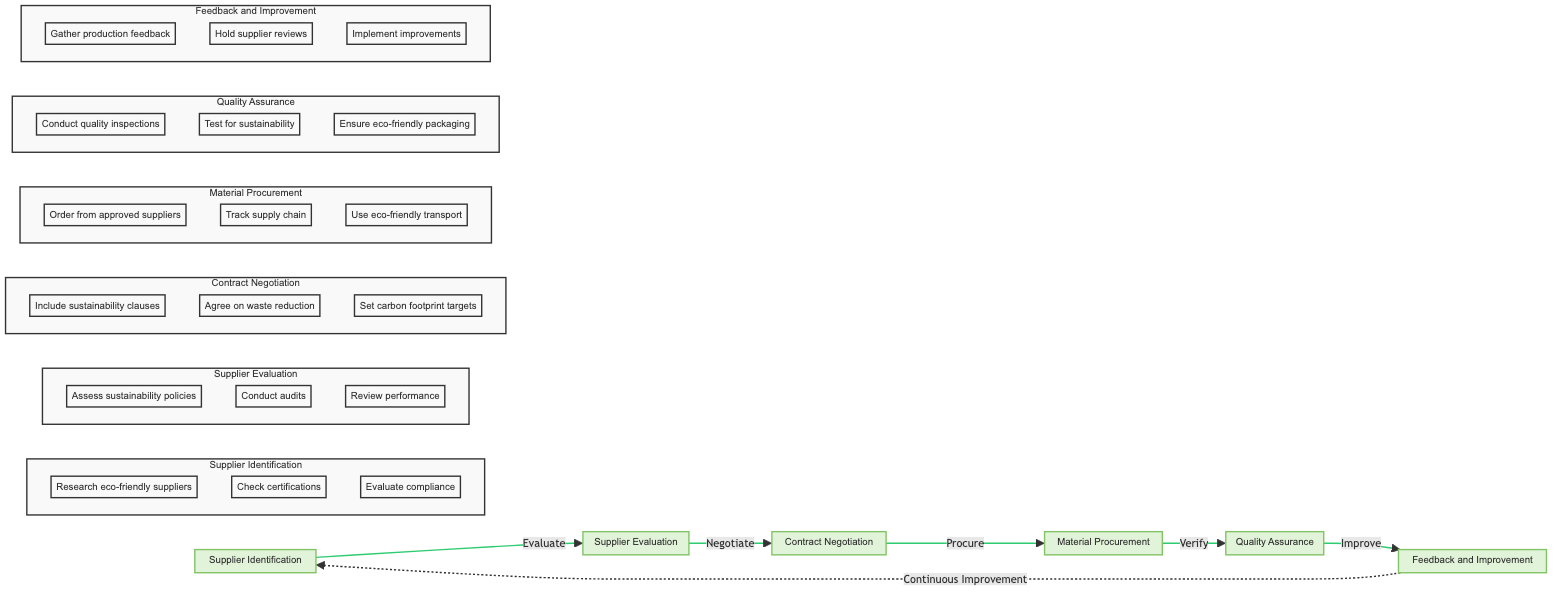What are the main steps in the sustainable material procurement process? The diagram outlines six main steps: Supplier Identification, Supplier Evaluation, Contract Negotiation, Material Procurement, Quality Assurance, and Feedback and Improvement.
Answer: Supplier Identification, Supplier Evaluation, Contract Negotiation, Material Procurement, Quality Assurance, Feedback and Improvement What is the starting point of the diagram? The horizontal flowchart begins with the Supplier Identification node, which is the first step in the sustainable material procurement process.
Answer: Supplier Identification How many nodes are in the diagram? The diagram contains six distinct nodes which represent the various steps in the sustainable material procurement process.
Answer: Six Which node comes after Contract Negotiation? Following Contract Negotiation, the next node is Material Procurement as indicated by the flow direction.
Answer: Material Procurement What action is associated with the Feedback and Improvement node? The Feedback and Improvement node is linked to the Continuous Improvement process, emphasizing the need for ongoing development after gathering feedback.
Answer: Continuous Improvement What is a step included in Supplier Evaluation? One of the steps in Supplier Evaluation is to conduct audits, which helps validate the sustainability practices of potential suppliers.
Answer: Conduct audits How do you achieve the Quality Assurance? Quality Assurance involves verifying the quality and sustainability of procured materials by conducting various quality inspections and tests for compliance with sustainability standards.
Answer: Conduct quality inspections, Test for sustainability, Ensure eco-friendly packaging What is the relationship between Quality Assurance and Feedback and Improvement? Quality Assurance leads to Feedback and Improvement, showing that the process of assessing material quality informs subsequent improvements in procurement practices.
Answer: Improve What is the purpose of the Contract Negotiation node? The purpose of the Contract Negotiation node is to negotiate terms that prioritize sustainable practices, ensuring that sustainability is integrated into supplier agreements.
Answer: Negotiate terms prioritizing sustainable practices 